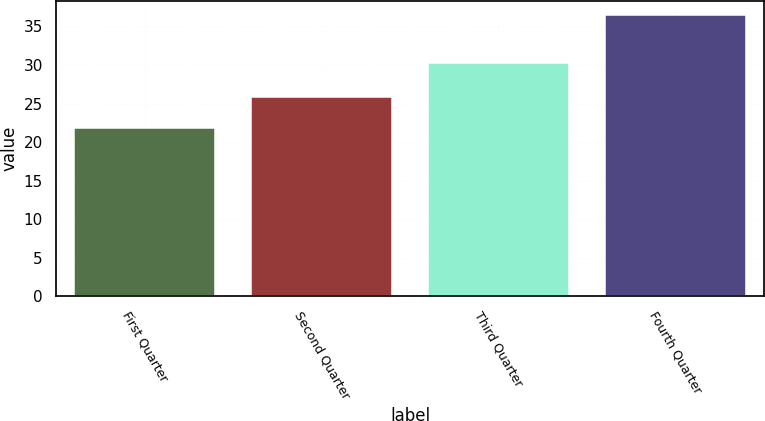<chart> <loc_0><loc_0><loc_500><loc_500><bar_chart><fcel>First Quarter<fcel>Second Quarter<fcel>Third Quarter<fcel>Fourth Quarter<nl><fcel>21.79<fcel>25.83<fcel>30.3<fcel>36.52<nl></chart> 